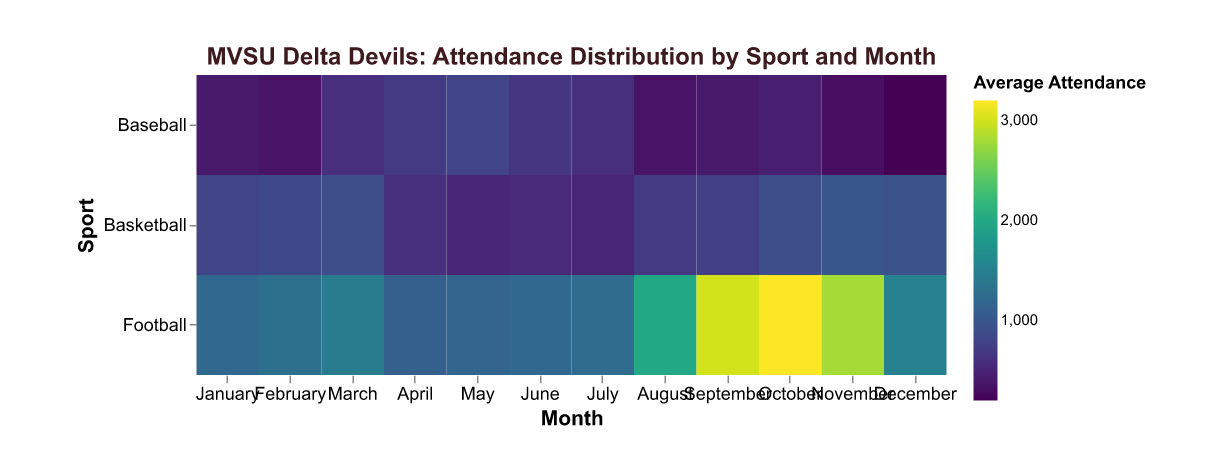What is the average attendance for Football games in October? Look at the cell where 'Football' intersects with 'October' on the heatmap. The value is the average attendance.
Answer: 3200 Which sport has the lowest average attendance in February? Compare the average attendance values for all sports in February. The sport with the smallest value has the lowest attendance.
Answer: Baseball During which month does Basketball have the highest average attendance? Compare the values across all months for Basketball and identify the highest value. Note the corresponding month.
Answer: November How does the average attendance for Football in August compare to November? Find the values for Football in August and November. Compare the two numbers to see which is higher or if they are equal.
Answer: Attendance is higher in August What is the total average attendance for Baseball over the months of March, April, and May? Sum up the average attendance values for Baseball in March, April, and May. March: 600, April: 700, May: 800. The total attendance is 600 + 700 + 800 = 2100.
Answer: 2100 Which month shows the highest overall average attendance across all sports? Sum up the average attendances for all sports for each month, then determine which month has the highest total.
Answer: October What is the difference in average attendance between Football and Basketball in December? Find the values for Football and Basketball in December, then subtract the Basketball value from the Football value.
Answer: 550 Is there a month where all three sports have their lowest average attendance? Identify the lowest average attendance for each sport, check if they occur in the same month. Football: 1100, Basketball: 500, Baseball: 200. No single month has all their lowest values.
Answer: No How does the average attendance for Football in September compare to the highest average attendance for Basketball? Find the highest value for Basketball and the value for Football in September. Compare them to see which is higher.
Answer: Football in September is higher Which sport experiences the largest increase in average attendance from July to August? Calculate the difference between August and July for each sport, then determine which sport has the largest increase. Football: 2000-1250 = 750, Basketball: 700-500 = 200, Baseball: 350-600 = -250. Football shows the largest increase.
Answer: Football 